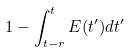<formula> <loc_0><loc_0><loc_500><loc_500>1 - \int _ { t - r } ^ { t } E ( t ^ { \prime } ) d t ^ { \prime }</formula> 